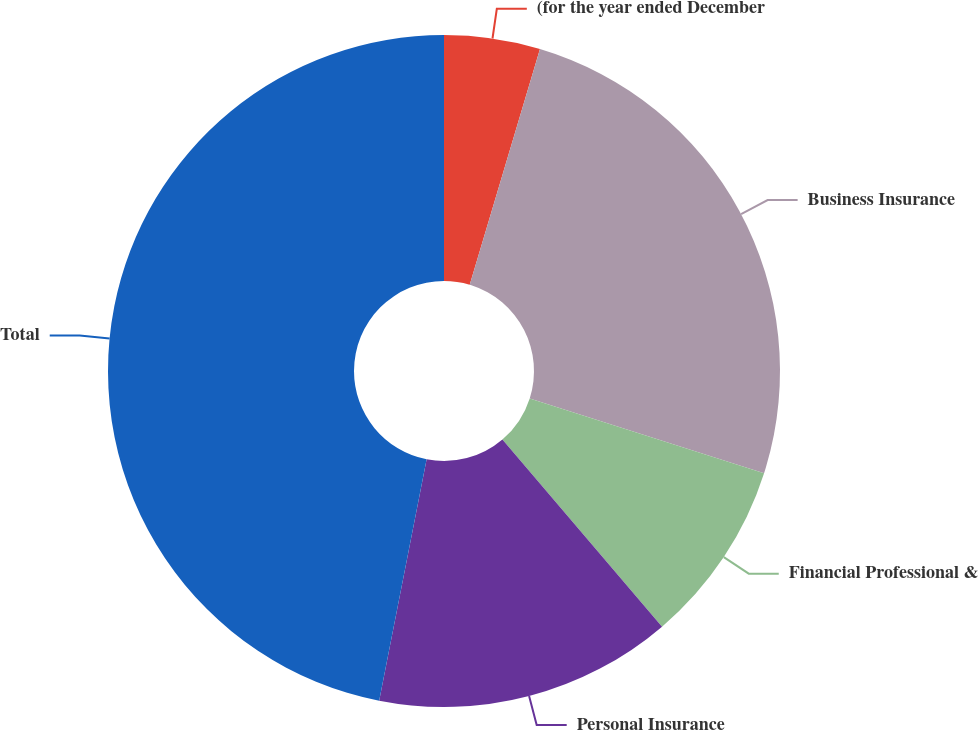<chart> <loc_0><loc_0><loc_500><loc_500><pie_chart><fcel>(for the year ended December<fcel>Business Insurance<fcel>Financial Professional &<fcel>Personal Insurance<fcel>Total<nl><fcel>4.61%<fcel>25.31%<fcel>8.84%<fcel>14.33%<fcel>46.91%<nl></chart> 